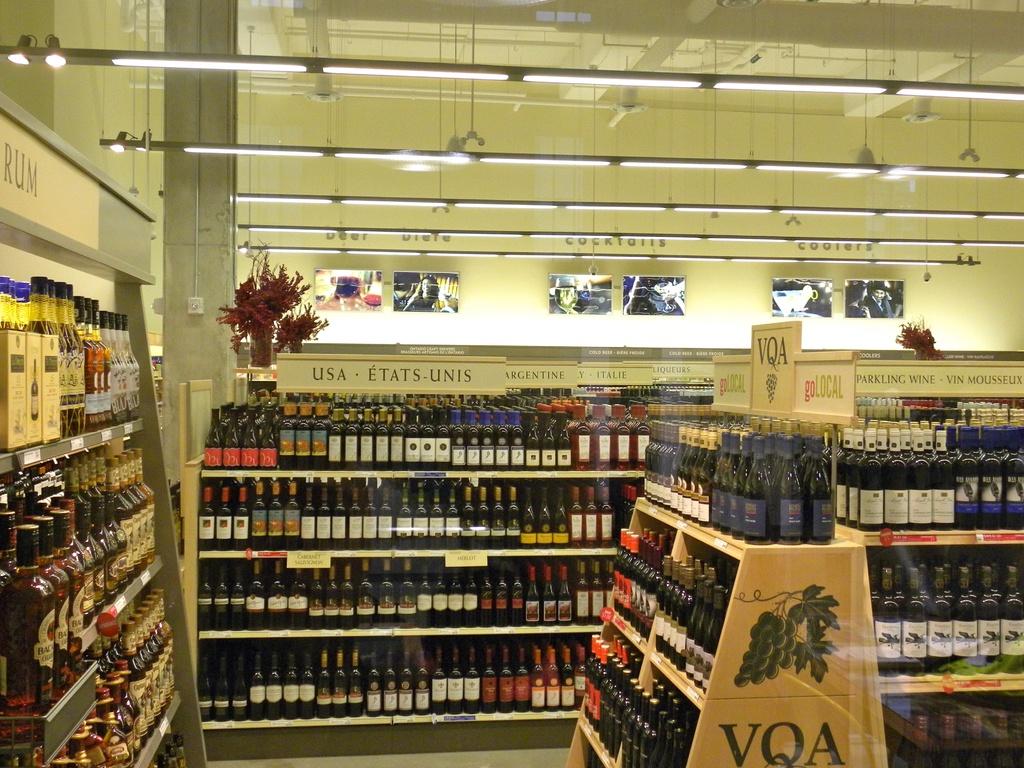Which country are the wine displayed in the middle from?
Your answer should be very brief. Usa. What are the letters of the shelf at the front?
Make the answer very short. Vqa. 